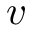Convert formula to latex. <formula><loc_0><loc_0><loc_500><loc_500>v</formula> 